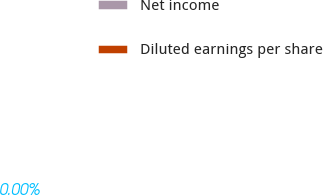<chart> <loc_0><loc_0><loc_500><loc_500><pie_chart><fcel>Net income<fcel>Diluted earnings per share<nl><fcel>100.0%<fcel>0.0%<nl></chart> 